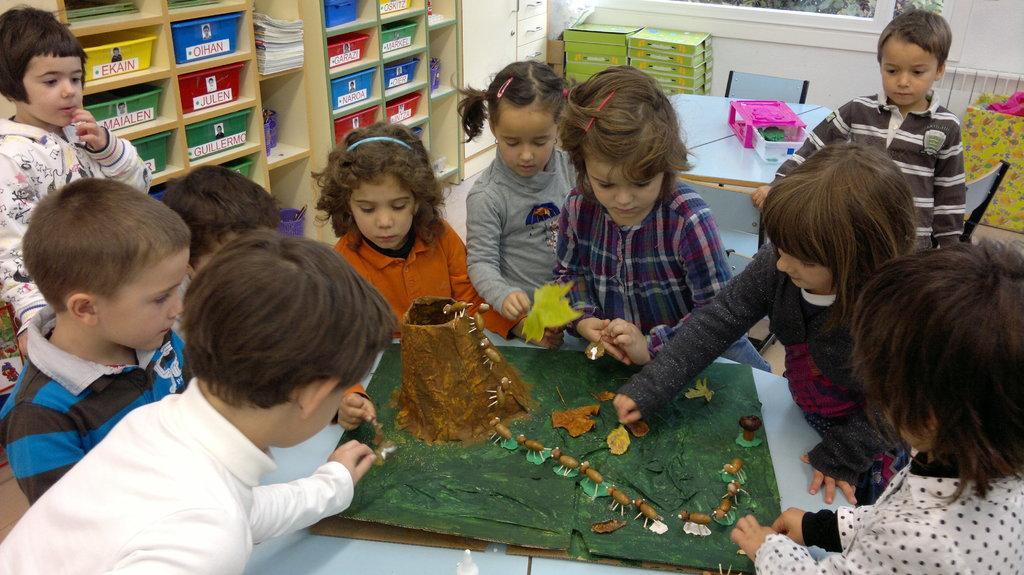Can you describe this image briefly? In the image few kids are standing and sitting surrounding a table, on the table we can see an object and few kids are holding some leafs and some objects. Behind them we can see a table and chair, on the table we can see some objects. At the top of the image we can see some cupboards and wall. 